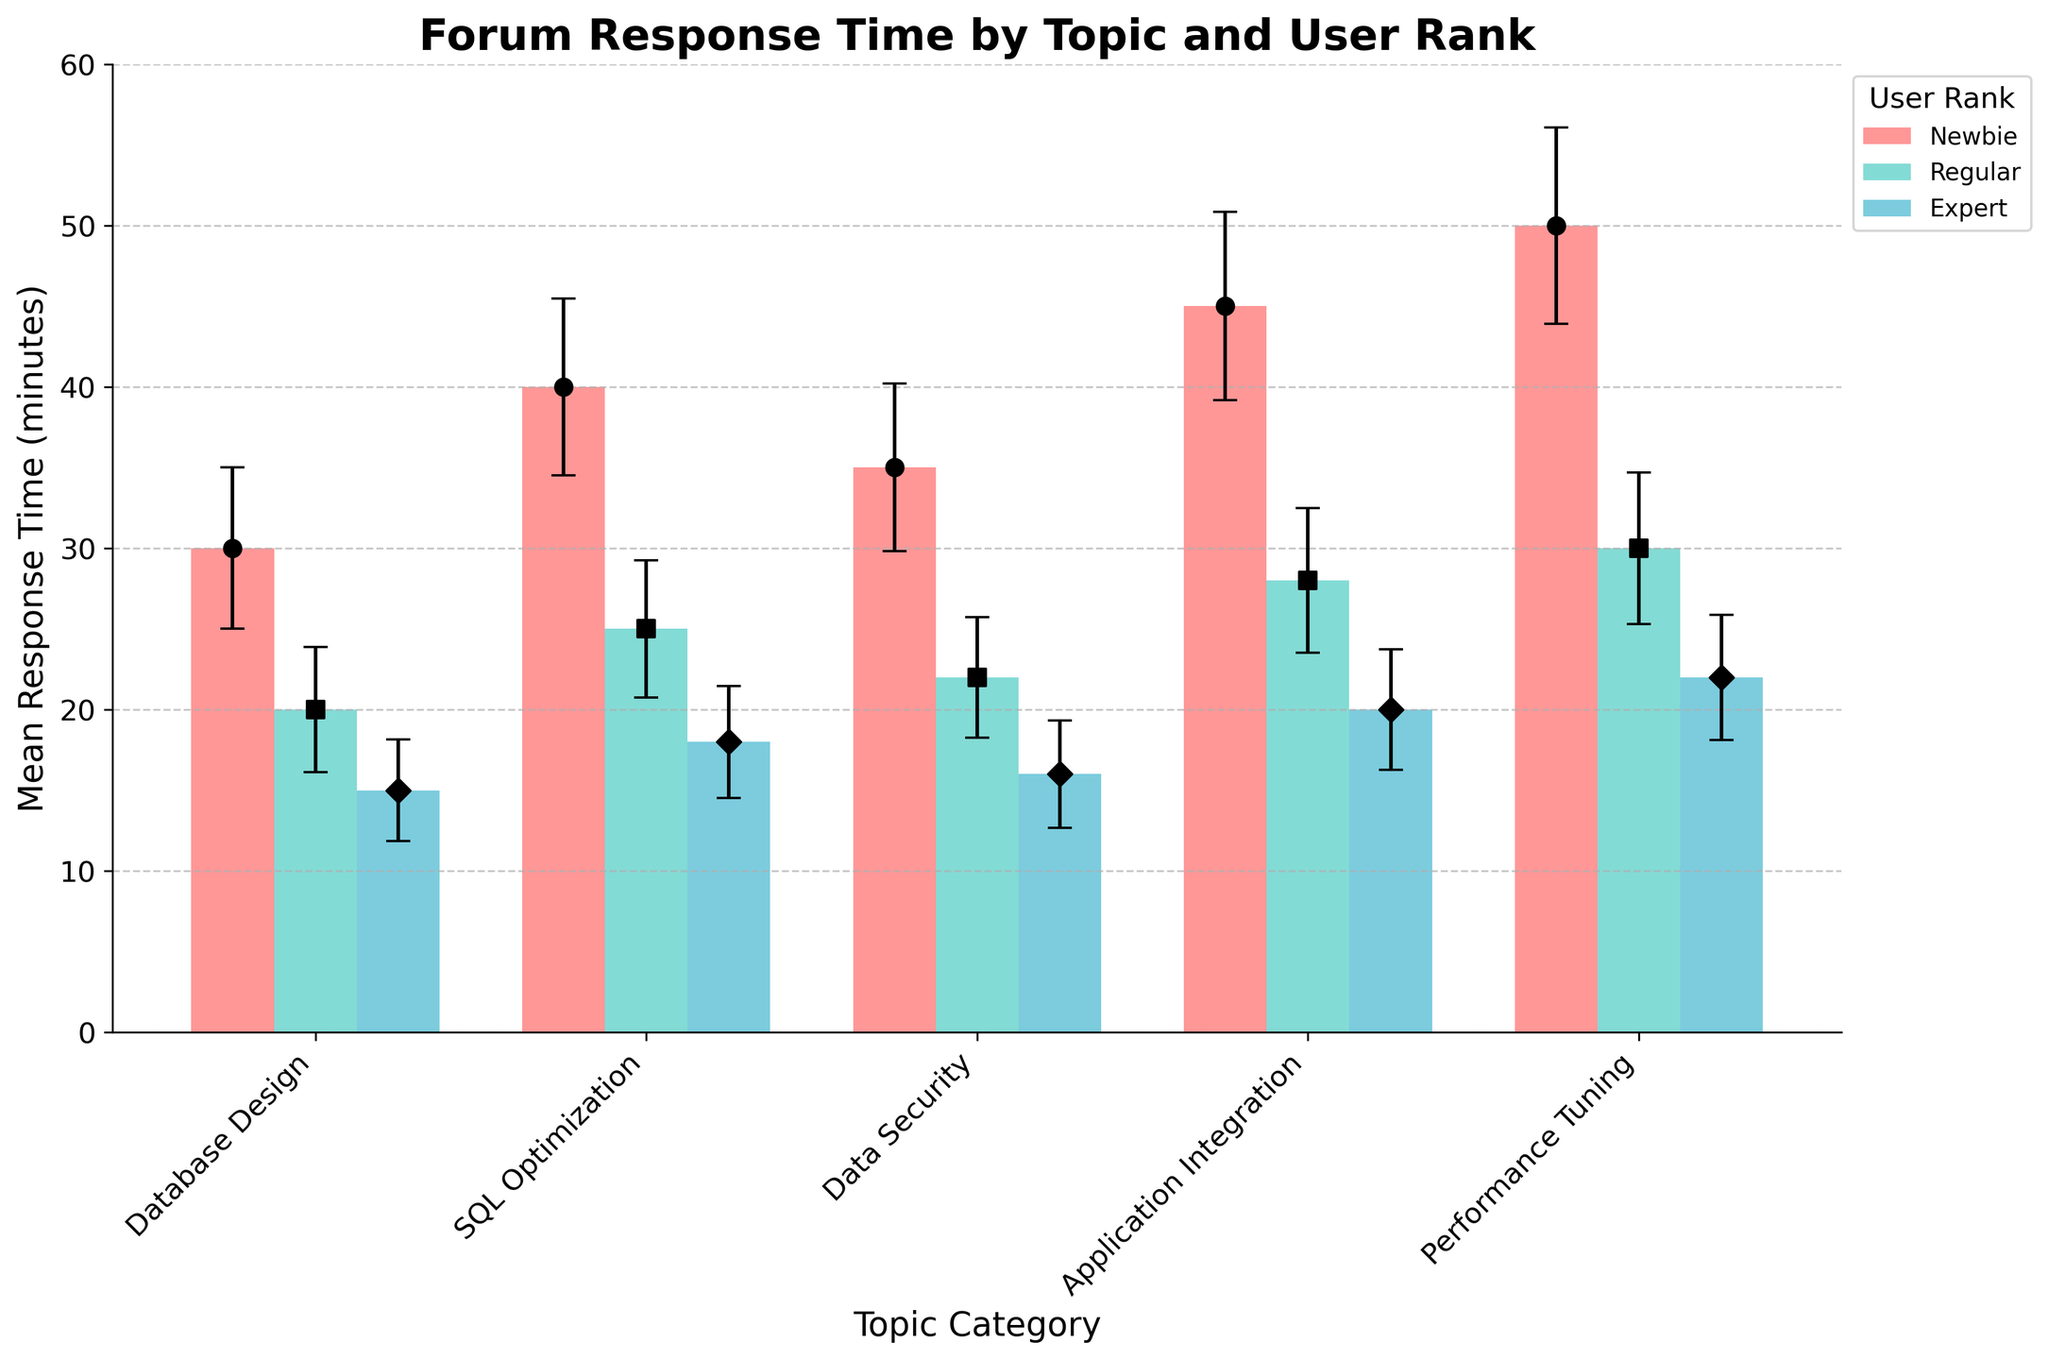What is the general trend of mean response time as the user rank increases for all topic categories? For all topic categories, mean response time decreases as user rank increases from Newbie to Regular to Expert.
Answer: Decreases Which topic category has the highest mean response time for Newbies? By examining the highest bar among the Newbie axis, Performance Tuning has the highest mean response time at 50 minutes.
Answer: Performance Tuning What is the mean response time difference between Experts and Newbies for SQL Optimization? The mean response time for Experts is 18 minutes, and for Newbies, it is 40 minutes. The difference is 40 - 18.
Answer: 22 minutes Which user rank category consistently has the lowest response time variance across all topic categories? By observing the error bars, Experts have the smallest error bars indicating the lowest variance across all topic categories.
Answer: Experts In which topic category does Regulars have the smallest mean response time? By examining the bars for Regulars, Database Design has the smallest mean response time of 20 minutes.
Answer: Database Design How does the mean response time vary across different user ranks within the topic category "Data Security"? For Data Security, Newbies average 35 minutes, Regulars average 22 minutes, and Experts average 16 minutes.
Answer: 35 (Newbie), 22 (Regular), 16 (Expert) What is the average response time for Regular users across all topic categories? The mean response times for Regular users are: 20, 25, 22, 28, and 30. The sum is 125, and there are 5 categories. 125/5 = 25.
Answer: 25 Which topic category shows the largest mean response time decrease from Newbies to Experts? By comparing the bars, Performance Tuning shows the largest decrease from 50 minutes (Newbies) to 22 minutes (Experts), a difference of 28 minutes.
Answer: Performance Tuning Are there any topic categories where the variance in response time remains relatively stable across different user ranks? Database Design shows a relatively stable variance in response time, as each user rank has a small error bar.
Answer: Database Design What's the average variance in response time for the Newbie user rank across all topic categories? The variances are: 25, 30, 27, 34, and 37. The sum is 153, and there are 5 categories. 153/5 = 30.6.
Answer: 30.6 